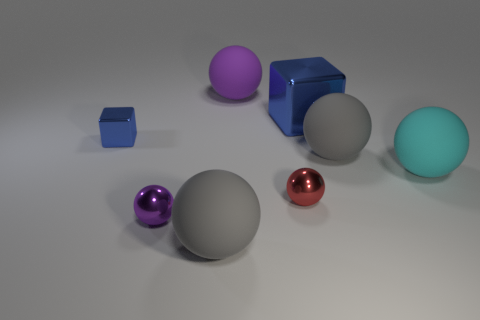Subtract 2 balls. How many balls are left? 4 Subtract all cyan balls. How many balls are left? 5 Subtract all purple shiny spheres. How many spheres are left? 5 Subtract all blue balls. Subtract all green cylinders. How many balls are left? 6 Subtract all cubes. How many objects are left? 6 Subtract all gray things. Subtract all cyan rubber spheres. How many objects are left? 5 Add 3 red things. How many red things are left? 4 Add 5 tiny brown matte objects. How many tiny brown matte objects exist? 5 Subtract 1 cyan balls. How many objects are left? 7 